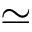Convert formula to latex. <formula><loc_0><loc_0><loc_500><loc_500>\simeq</formula> 